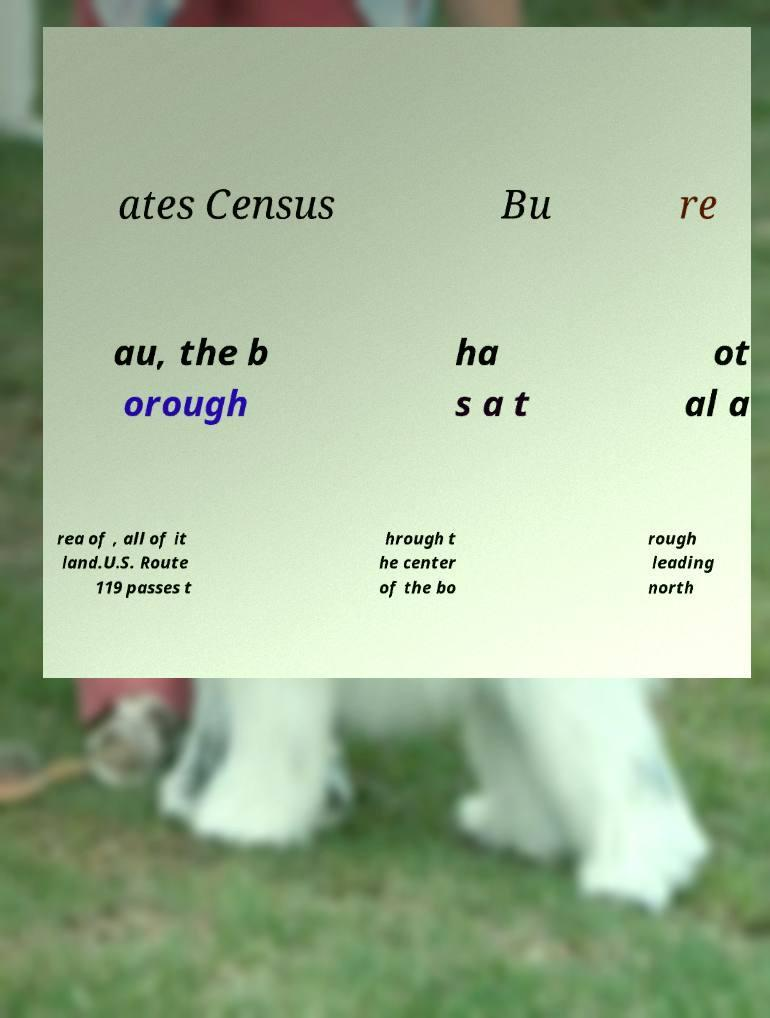Can you accurately transcribe the text from the provided image for me? ates Census Bu re au, the b orough ha s a t ot al a rea of , all of it land.U.S. Route 119 passes t hrough t he center of the bo rough leading north 